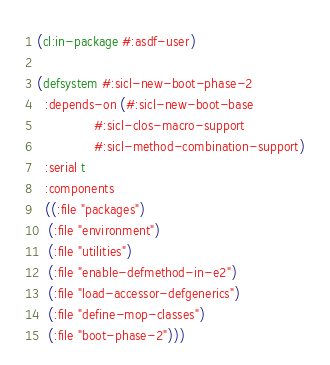<code> <loc_0><loc_0><loc_500><loc_500><_Lisp_>(cl:in-package #:asdf-user)

(defsystem #:sicl-new-boot-phase-2
  :depends-on (#:sicl-new-boot-base
               #:sicl-clos-macro-support
               #:sicl-method-combination-support)
  :serial t
  :components
  ((:file "packages")
   (:file "environment")
   (:file "utilities")
   (:file "enable-defmethod-in-e2")
   (:file "load-accessor-defgenerics")
   (:file "define-mop-classes")
   (:file "boot-phase-2")))
</code> 